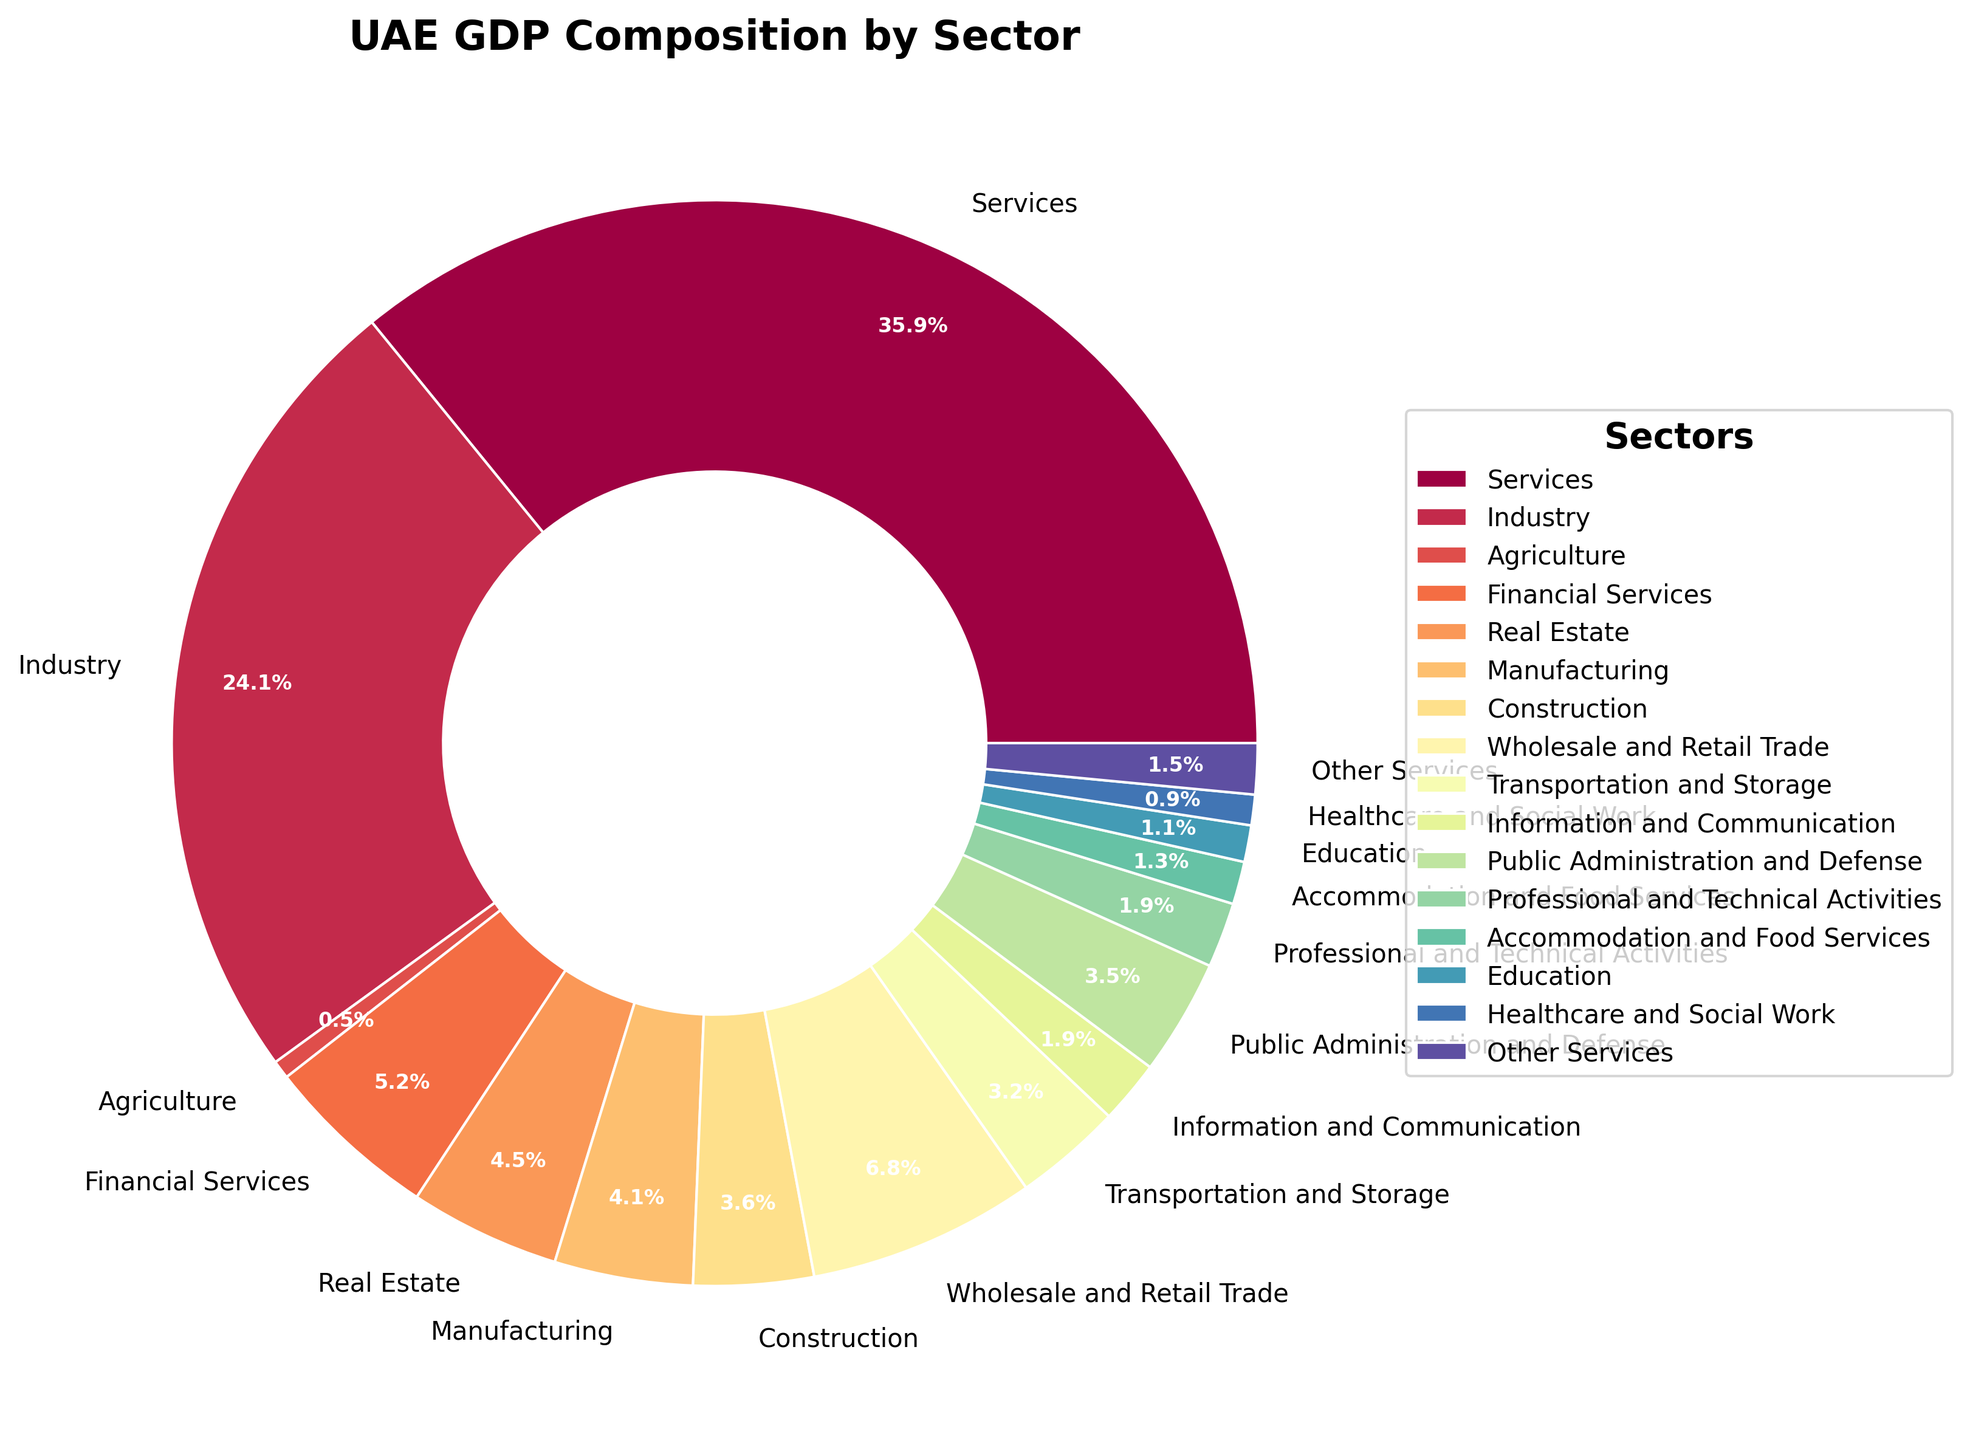What percentage of UAE's GDP does the services sector contribute? Refer to the segment labeled "Services" on the pie chart. The percentage shown there is 59.2%.
Answer: 59.2% Which sector has the smallest contribution to UAE's GDP and what is its percentage? Look for the smallest segment in the pie chart, which is labeled "Agriculture". The percentage for this sector is 0.9%.
Answer: Agriculture, 0.9% How does the contribution of the real estate sector compare to the financial services sector? Refer to the two segments labeled "Real Estate" and "Financial Services". The real estate sector is 7.4% and financial services sector is 8.6%.
Answer: Financial Services > Real Estate What is the combined GDP contribution of the manufacturing, construction, and information and communication sectors? Add the percentages of the "Manufacturing" (6.8%), "Construction" (5.9%), and "Information and Communication" (3.1%) sectors. 6.8 + 5.9 + 3.1 = 15.8.
Answer: 15.8% Which sector has the largest segment visually and what is its color? Identify the largest segment on the pie chart. It is the "Services" sector, and its color can be visually spotted in the figure.
Answer: Services, [answer can be added depending on the visible color] Compare the contributions of the wholesale and retail trade sector to the transportation and storage sector. Which one is larger? Refer to the segments labeled "Wholesale and Retail Trade" (11.2%) and "Transportation and Storage" (5.3%). Compare the two percentages.
Answer: Wholesale and Retail Trade > Transportation and Storage What is the percentage difference between the industry sector and the public administration and defense sector? Subtract the percentage of the "Public Administration and Defense" (5.7%) from the "Industry" sector (39.8%). 39.8 - 5.7 = 34.1.
Answer: 34.1% What is the average GDP contribution of sectors contributing less than 3% each? Identify sectors with <3% contributions: "Information and Communication" (3.1%), "Education" (1.8%), "Healthcare and Social Work" (1.5%), "Accommodation and Food Services" (2.1%), "Professional and Technical Activities" (3.2%), "Other Services" (2.5%). Average = (3.1 + 1.8 + 1.5 + 2.1 + 3.2 + 2.5) / 6 = 2.37.
Answer: 2.37 Does the services sector contribute more than all the other sectors combined? Calculate the sum of the percentages of all sectors except "Services". The total of all sectors is 100%. Excluding services (59.2%), the sum of remaining sectors is 40.8%. Services contributes 59.2%, which is more than 40.8%.
Answer: Yes How does the healthcare and social work sector's percentage compare to education and accommodation and food services? Refer to the segments labeled "Healthcare and Social Work" (1.5%), "Education" (1.8%) and "Accommodation and Food Services" (2.1%).
Answer: Accommodation and Food Services > Education > Healthcare and Social Work 